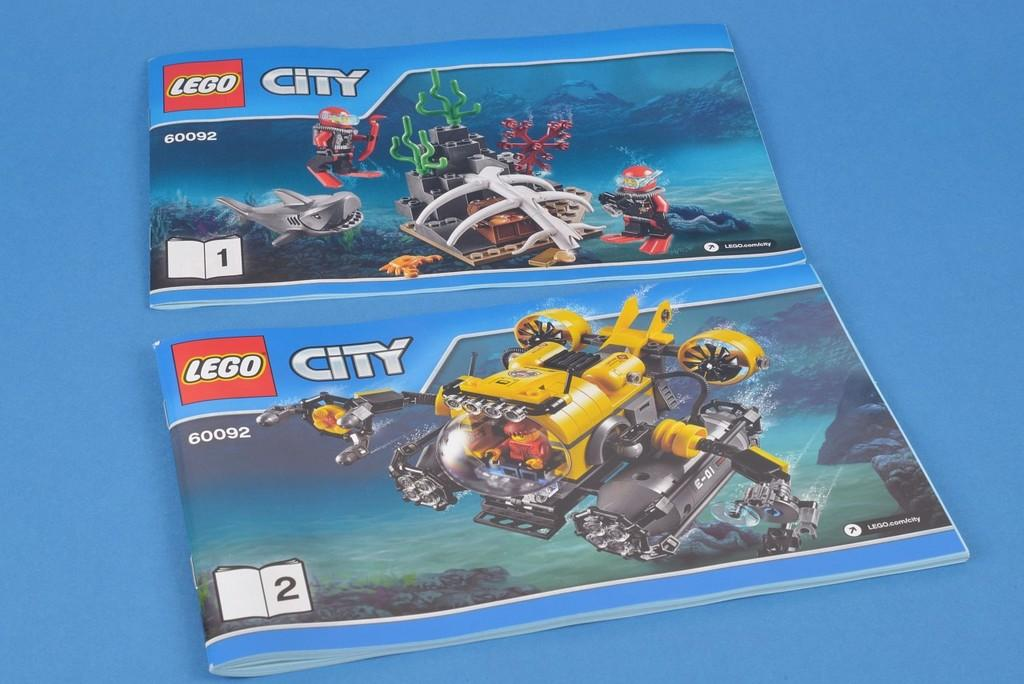How many books are visible in the image? There are two books in the image. What is the surface on which the books are placed? The books are placed on a blue surface. What can be seen on the book covers? The book covers have images and text. What type of dress is the book wearing in the image? Books do not wear dresses; they are inanimate objects. 